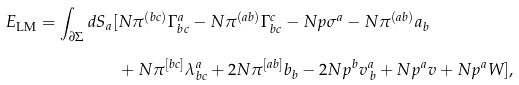Convert formula to latex. <formula><loc_0><loc_0><loc_500><loc_500>E _ { \text {LM} } = \int _ { \partial \Sigma } d S _ { a } [ & N \pi ^ { ( b c ) } \Gamma ^ { a } _ { b c } - N \pi ^ { ( a b ) } \Gamma ^ { c } _ { b c } - N p \sigma ^ { a } - N \pi ^ { ( a b ) } a _ { b } \\ & + N \pi ^ { [ b c ] } \lambda ^ { a } _ { b c } + 2 N \pi ^ { [ a b ] } b _ { b } - 2 N p ^ { b } v ^ { a } _ { \, b } + N p ^ { a } v + N p ^ { a } W ] ,</formula> 